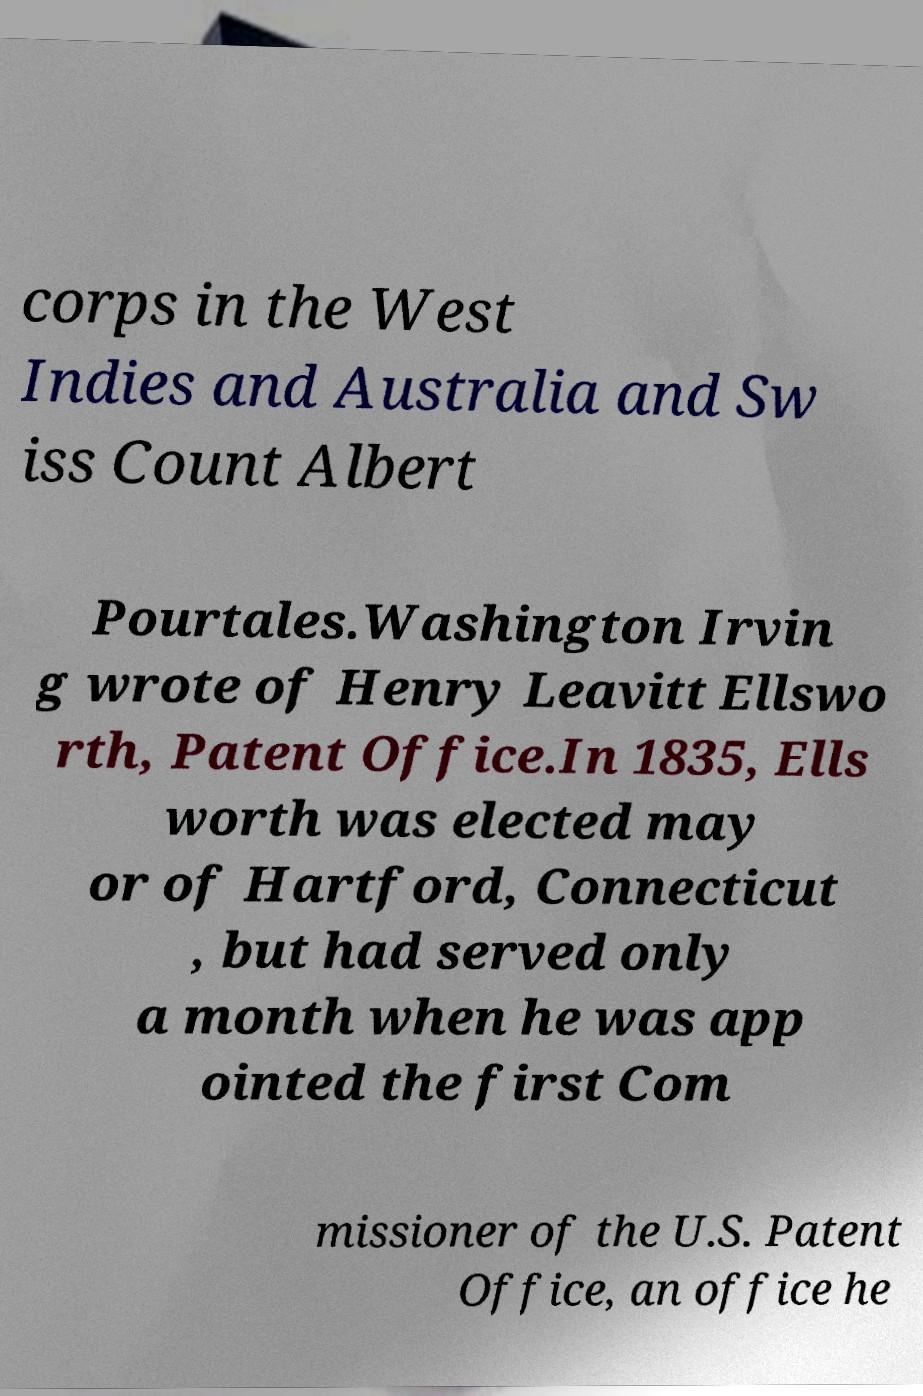Please read and relay the text visible in this image. What does it say? corps in the West Indies and Australia and Sw iss Count Albert Pourtales.Washington Irvin g wrote of Henry Leavitt Ellswo rth, Patent Office.In 1835, Ells worth was elected may or of Hartford, Connecticut , but had served only a month when he was app ointed the first Com missioner of the U.S. Patent Office, an office he 